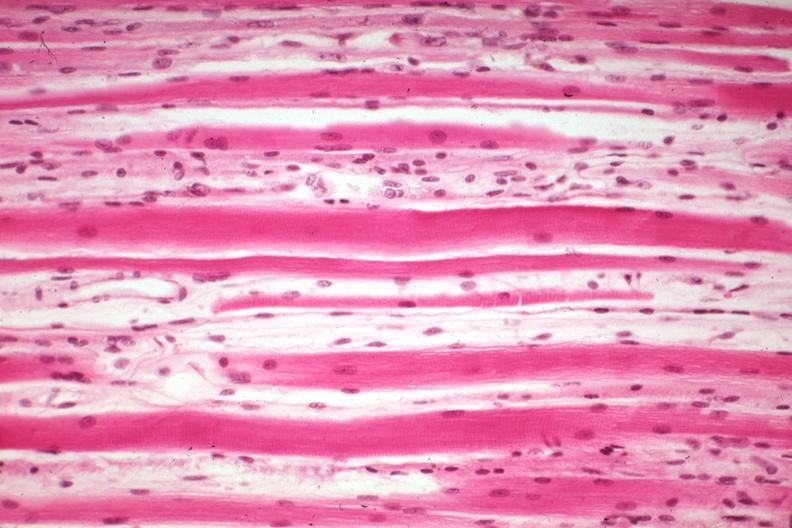s high excellent steroid induced atrophy?
Answer the question using a single word or phrase. Yes 